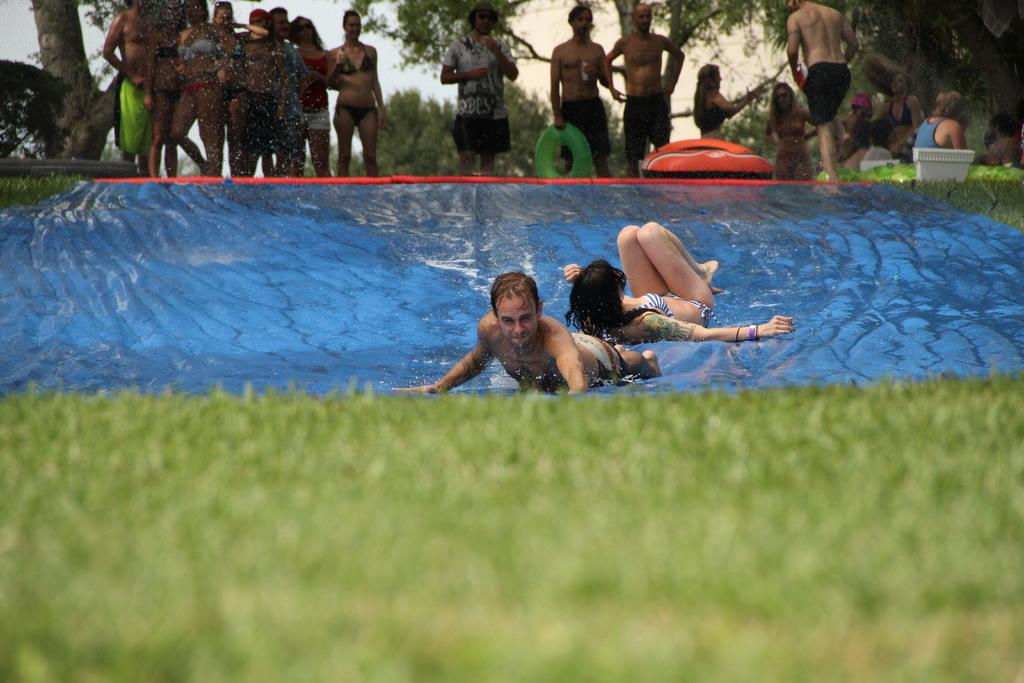How many people are in the image? There are people in the image. What are two people doing in the image? Two people are swimming in the water. What type of vegetation is present in the image? There are trees in the image. What else can be seen in the image besides people and trees? There are objects and grass in the image. Are there any jellyfish visible in the water where the people are swimming? There is no mention of jellyfish in the image, so we cannot determine their presence. What type of ornament is hanging from the trees in the image? There is no mention of an ornament in the image, so we cannot determine its presence. 